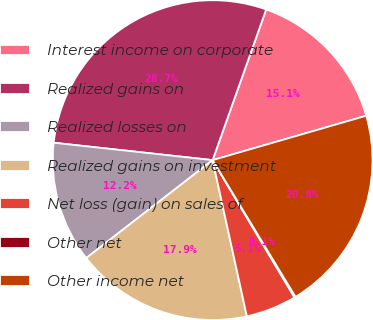<chart> <loc_0><loc_0><loc_500><loc_500><pie_chart><fcel>Interest income on corporate<fcel>Realized gains on<fcel>Realized losses on<fcel>Realized gains on investment<fcel>Net loss (gain) on sales of<fcel>Other net<fcel>Other income net<nl><fcel>15.09%<fcel>28.7%<fcel>12.23%<fcel>17.94%<fcel>5.12%<fcel>0.12%<fcel>20.8%<nl></chart> 